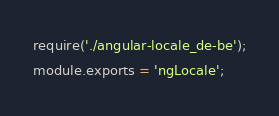Convert code to text. <code><loc_0><loc_0><loc_500><loc_500><_JavaScript_>require('./angular-locale_de-be');
module.exports = 'ngLocale';
</code> 